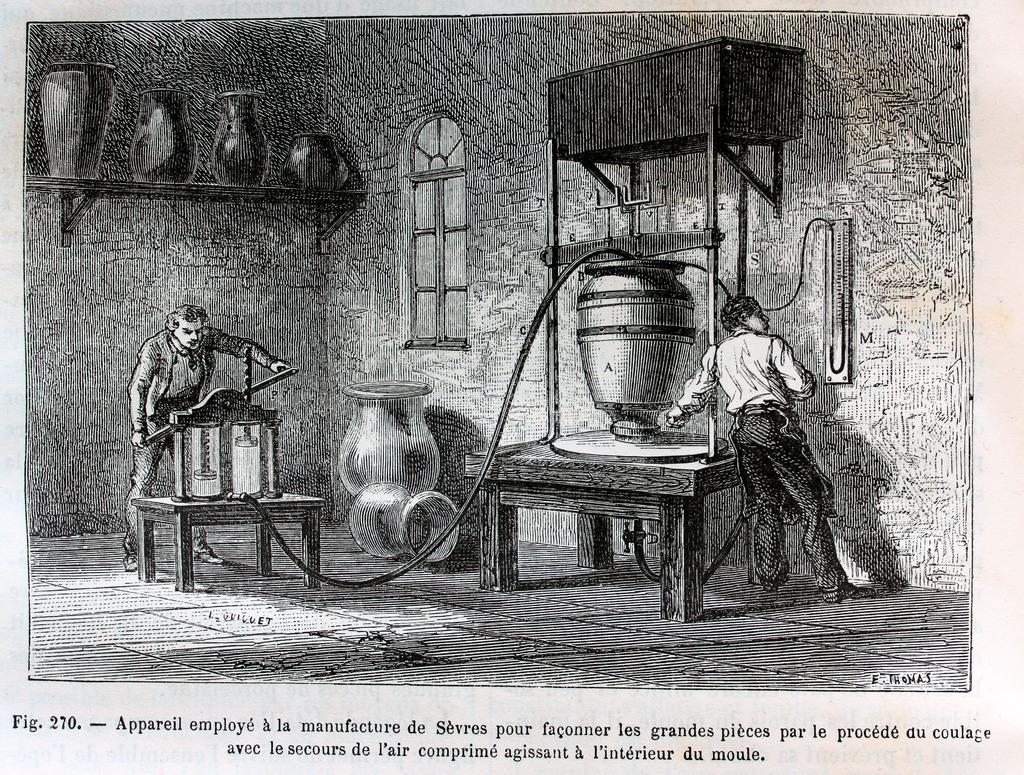Can you describe this image briefly? In this image we can see a paper and on the paper we can see a person operating a machine. We can also see another person standing on the floor and checking the meter which is attached to the wall. Image also consists of some vessels on the counter. We can also see the window. At the bottom there is text. 